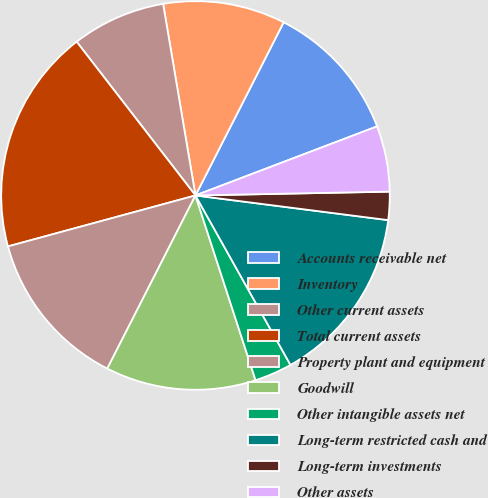Convert chart to OTSL. <chart><loc_0><loc_0><loc_500><loc_500><pie_chart><fcel>Accounts receivable net<fcel>Inventory<fcel>Other current assets<fcel>Total current assets<fcel>Property plant and equipment<fcel>Goodwill<fcel>Other intangible assets net<fcel>Long-term restricted cash and<fcel>Long-term investments<fcel>Other assets<nl><fcel>11.72%<fcel>10.16%<fcel>7.81%<fcel>18.75%<fcel>13.28%<fcel>12.5%<fcel>3.13%<fcel>14.84%<fcel>2.34%<fcel>5.47%<nl></chart> 